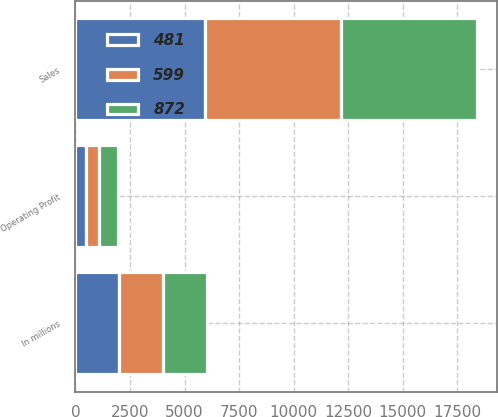Convert chart. <chart><loc_0><loc_0><loc_500><loc_500><stacked_bar_chart><ecel><fcel>In millions<fcel>Sales<fcel>Operating Profit<nl><fcel>599<fcel>2012<fcel>6230<fcel>599<nl><fcel>872<fcel>2011<fcel>6215<fcel>872<nl><fcel>481<fcel>2010<fcel>5940<fcel>481<nl></chart> 